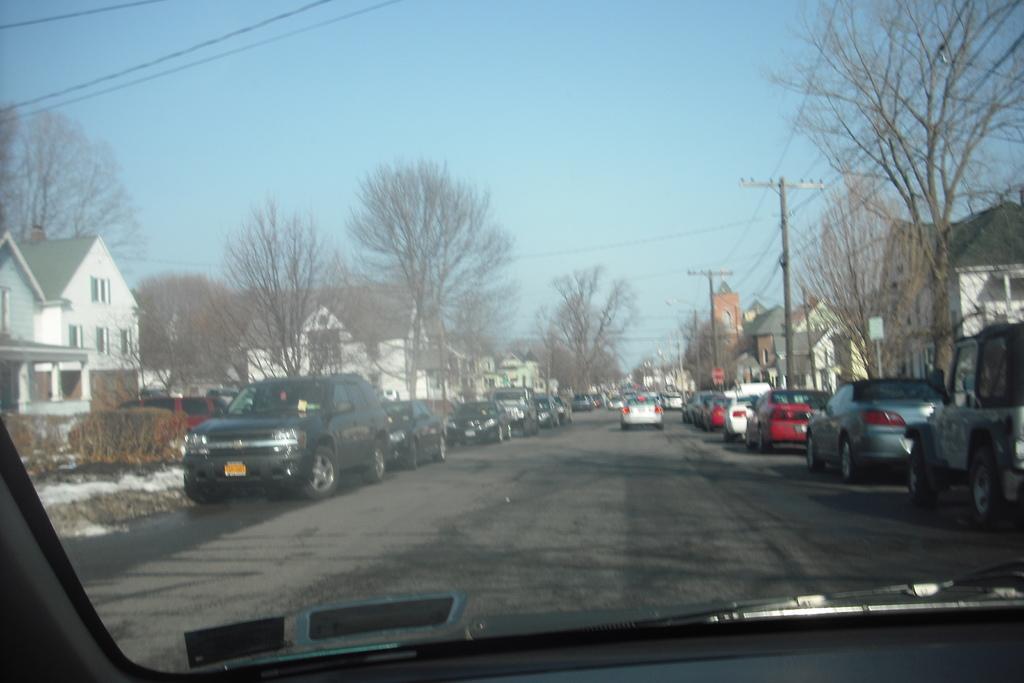Can you describe this image briefly? In this image we can see motor vehicles, electric poles, electric cables, trees, buildings and sky through a vehicle's mirror. 